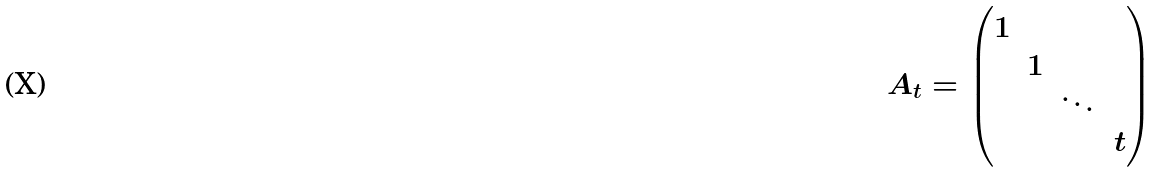<formula> <loc_0><loc_0><loc_500><loc_500>A _ { t } = \begin{pmatrix} 1 \\ & 1 \\ & & \ddots \\ & & & t \end{pmatrix}</formula> 